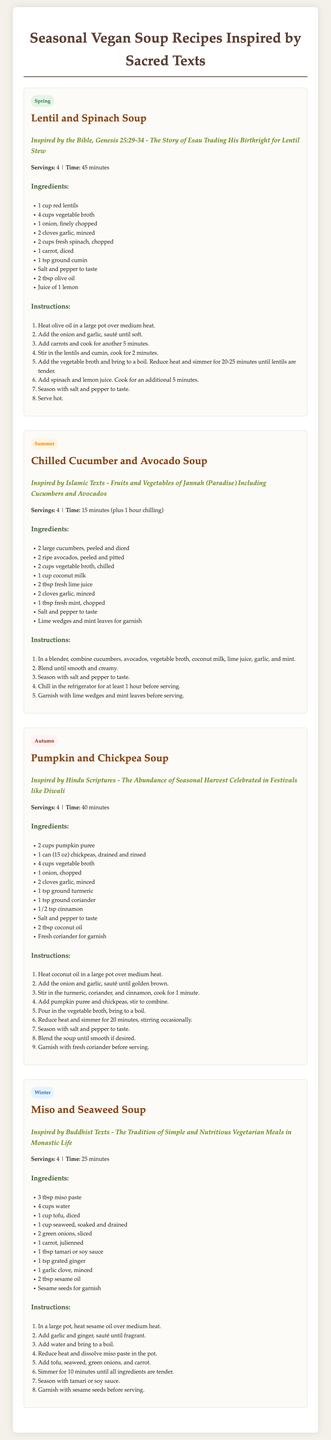What is the title of the document? The title is displayed prominently at the top of the document and indicates the content within it.
Answer: Seasonal Vegan Soup Recipes Inspired by Sacred Texts How many servings does the Lentil and Spinach Soup yield? The number of servings is specified under the recipe details for Lentil and Spinach Soup.
Answer: 4 What is the total time for preparing the Chilled Cucumber and Avocado Soup? The total time is explicitly mentioned under the recipe details, including preparation and chilling time.
Answer: 1 hour 15 minutes What vegetable is the main ingredient in the Pumpkin and Chickpea Soup? The main ingredient is highlighted in the ingredients list as well as in the recipe title.
Answer: Pumpkin Which season is the Miso and Seaweed Soup associated with? The season label is displayed prominently at the top of the respective recipe section.
Answer: Winter What is the primary inspiration for the Chilled Cucumber and Avocado Soup? The inspiration is given in the heading of the recipe section, noting its roots in a specific religious text.
Answer: Islamic Texts How many ingredients are listed for the Autumn recipe? The number of ingredients can be determined by counting them in the ingredients section of the Pumpkin and Chickpea Soup.
Answer: 10 What cooking method is used for the Lentil and Spinach Soup? The method is described through a series of instructions, which indicate the use of heat in preparation.
Answer: Sautéing and simmering What garnish is suggested for the Miso and Seaweed Soup? The garnish is mentioned at the end of the ingredients list and adds a finishing touch to the dish.
Answer: Sesame seeds 